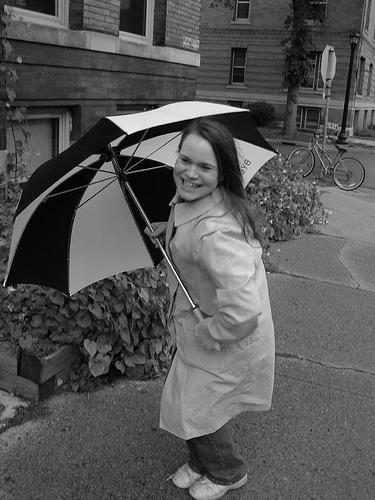What color is the woman's coat?
Quick response, please. White. Is the girl wearing a bikini?
Give a very brief answer. No. Is she happy?
Be succinct. Yes. Where is the girl's left arm?
Keep it brief. Umbrella. How long is her hair?
Quick response, please. Shoulder length. Was it taken in Summer?
Be succinct. No. How many people are under the umbrella?
Short answer required. 1. What is her jacket called?
Quick response, please. Raincoat. Is the woman wearing sneakers?
Be succinct. Yes. Is she  holding something?
Be succinct. Yes. 